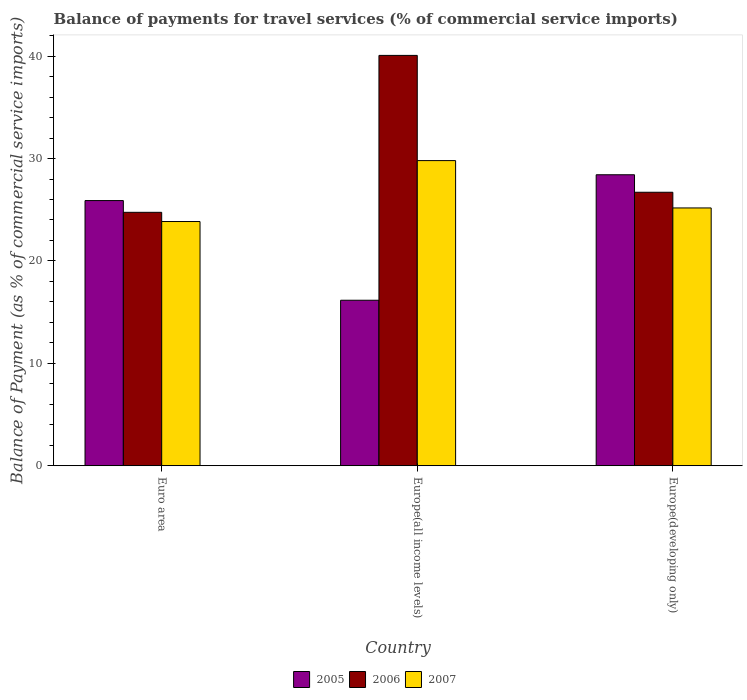How many different coloured bars are there?
Offer a very short reply. 3. Are the number of bars on each tick of the X-axis equal?
Keep it short and to the point. Yes. How many bars are there on the 2nd tick from the left?
Make the answer very short. 3. How many bars are there on the 3rd tick from the right?
Your answer should be compact. 3. What is the label of the 2nd group of bars from the left?
Your answer should be very brief. Europe(all income levels). In how many cases, is the number of bars for a given country not equal to the number of legend labels?
Offer a terse response. 0. What is the balance of payments for travel services in 2007 in Europe(all income levels)?
Offer a very short reply. 29.8. Across all countries, what is the maximum balance of payments for travel services in 2005?
Ensure brevity in your answer.  28.42. Across all countries, what is the minimum balance of payments for travel services in 2007?
Offer a terse response. 23.85. In which country was the balance of payments for travel services in 2006 maximum?
Your answer should be very brief. Europe(all income levels). What is the total balance of payments for travel services in 2007 in the graph?
Your answer should be very brief. 78.82. What is the difference between the balance of payments for travel services in 2007 in Euro area and that in Europe(developing only)?
Make the answer very short. -1.33. What is the difference between the balance of payments for travel services in 2005 in Europe(all income levels) and the balance of payments for travel services in 2007 in Euro area?
Make the answer very short. -7.69. What is the average balance of payments for travel services in 2007 per country?
Make the answer very short. 26.27. What is the difference between the balance of payments for travel services of/in 2007 and balance of payments for travel services of/in 2006 in Europe(all income levels)?
Give a very brief answer. -10.27. What is the ratio of the balance of payments for travel services in 2005 in Euro area to that in Europe(all income levels)?
Provide a succinct answer. 1.6. Is the balance of payments for travel services in 2005 in Euro area less than that in Europe(developing only)?
Your answer should be compact. Yes. What is the difference between the highest and the second highest balance of payments for travel services in 2006?
Your answer should be compact. 15.33. What is the difference between the highest and the lowest balance of payments for travel services in 2005?
Provide a short and direct response. 12.25. In how many countries, is the balance of payments for travel services in 2006 greater than the average balance of payments for travel services in 2006 taken over all countries?
Ensure brevity in your answer.  1. What does the 1st bar from the right in Europe(developing only) represents?
Provide a short and direct response. 2007. Is it the case that in every country, the sum of the balance of payments for travel services in 2005 and balance of payments for travel services in 2007 is greater than the balance of payments for travel services in 2006?
Your answer should be compact. Yes. How many bars are there?
Your answer should be very brief. 9. How many countries are there in the graph?
Give a very brief answer. 3. Does the graph contain any zero values?
Make the answer very short. No. Does the graph contain grids?
Offer a very short reply. No. Where does the legend appear in the graph?
Your answer should be very brief. Bottom center. How many legend labels are there?
Keep it short and to the point. 3. How are the legend labels stacked?
Provide a short and direct response. Horizontal. What is the title of the graph?
Provide a succinct answer. Balance of payments for travel services (% of commercial service imports). Does "1988" appear as one of the legend labels in the graph?
Make the answer very short. No. What is the label or title of the X-axis?
Your answer should be very brief. Country. What is the label or title of the Y-axis?
Offer a very short reply. Balance of Payment (as % of commercial service imports). What is the Balance of Payment (as % of commercial service imports) of 2005 in Euro area?
Keep it short and to the point. 25.89. What is the Balance of Payment (as % of commercial service imports) of 2006 in Euro area?
Your answer should be very brief. 24.75. What is the Balance of Payment (as % of commercial service imports) of 2007 in Euro area?
Your answer should be compact. 23.85. What is the Balance of Payment (as % of commercial service imports) in 2005 in Europe(all income levels)?
Your response must be concise. 16.16. What is the Balance of Payment (as % of commercial service imports) in 2006 in Europe(all income levels)?
Give a very brief answer. 40.07. What is the Balance of Payment (as % of commercial service imports) of 2007 in Europe(all income levels)?
Make the answer very short. 29.8. What is the Balance of Payment (as % of commercial service imports) of 2005 in Europe(developing only)?
Your answer should be compact. 28.42. What is the Balance of Payment (as % of commercial service imports) of 2006 in Europe(developing only)?
Give a very brief answer. 26.71. What is the Balance of Payment (as % of commercial service imports) of 2007 in Europe(developing only)?
Offer a terse response. 25.17. Across all countries, what is the maximum Balance of Payment (as % of commercial service imports) of 2005?
Provide a short and direct response. 28.42. Across all countries, what is the maximum Balance of Payment (as % of commercial service imports) of 2006?
Keep it short and to the point. 40.07. Across all countries, what is the maximum Balance of Payment (as % of commercial service imports) in 2007?
Your answer should be very brief. 29.8. Across all countries, what is the minimum Balance of Payment (as % of commercial service imports) of 2005?
Keep it short and to the point. 16.16. Across all countries, what is the minimum Balance of Payment (as % of commercial service imports) of 2006?
Offer a terse response. 24.75. Across all countries, what is the minimum Balance of Payment (as % of commercial service imports) of 2007?
Offer a terse response. 23.85. What is the total Balance of Payment (as % of commercial service imports) in 2005 in the graph?
Provide a succinct answer. 70.47. What is the total Balance of Payment (as % of commercial service imports) of 2006 in the graph?
Offer a very short reply. 91.52. What is the total Balance of Payment (as % of commercial service imports) in 2007 in the graph?
Keep it short and to the point. 78.82. What is the difference between the Balance of Payment (as % of commercial service imports) in 2005 in Euro area and that in Europe(all income levels)?
Your answer should be very brief. 9.73. What is the difference between the Balance of Payment (as % of commercial service imports) of 2006 in Euro area and that in Europe(all income levels)?
Keep it short and to the point. -15.33. What is the difference between the Balance of Payment (as % of commercial service imports) in 2007 in Euro area and that in Europe(all income levels)?
Your response must be concise. -5.95. What is the difference between the Balance of Payment (as % of commercial service imports) in 2005 in Euro area and that in Europe(developing only)?
Provide a succinct answer. -2.52. What is the difference between the Balance of Payment (as % of commercial service imports) of 2006 in Euro area and that in Europe(developing only)?
Ensure brevity in your answer.  -1.96. What is the difference between the Balance of Payment (as % of commercial service imports) in 2007 in Euro area and that in Europe(developing only)?
Keep it short and to the point. -1.33. What is the difference between the Balance of Payment (as % of commercial service imports) in 2005 in Europe(all income levels) and that in Europe(developing only)?
Make the answer very short. -12.25. What is the difference between the Balance of Payment (as % of commercial service imports) of 2006 in Europe(all income levels) and that in Europe(developing only)?
Your response must be concise. 13.37. What is the difference between the Balance of Payment (as % of commercial service imports) in 2007 in Europe(all income levels) and that in Europe(developing only)?
Your answer should be compact. 4.62. What is the difference between the Balance of Payment (as % of commercial service imports) in 2005 in Euro area and the Balance of Payment (as % of commercial service imports) in 2006 in Europe(all income levels)?
Your answer should be very brief. -14.18. What is the difference between the Balance of Payment (as % of commercial service imports) of 2005 in Euro area and the Balance of Payment (as % of commercial service imports) of 2007 in Europe(all income levels)?
Keep it short and to the point. -3.9. What is the difference between the Balance of Payment (as % of commercial service imports) of 2006 in Euro area and the Balance of Payment (as % of commercial service imports) of 2007 in Europe(all income levels)?
Your answer should be very brief. -5.05. What is the difference between the Balance of Payment (as % of commercial service imports) of 2005 in Euro area and the Balance of Payment (as % of commercial service imports) of 2006 in Europe(developing only)?
Ensure brevity in your answer.  -0.81. What is the difference between the Balance of Payment (as % of commercial service imports) in 2005 in Euro area and the Balance of Payment (as % of commercial service imports) in 2007 in Europe(developing only)?
Your answer should be compact. 0.72. What is the difference between the Balance of Payment (as % of commercial service imports) of 2006 in Euro area and the Balance of Payment (as % of commercial service imports) of 2007 in Europe(developing only)?
Provide a succinct answer. -0.43. What is the difference between the Balance of Payment (as % of commercial service imports) of 2005 in Europe(all income levels) and the Balance of Payment (as % of commercial service imports) of 2006 in Europe(developing only)?
Your answer should be very brief. -10.55. What is the difference between the Balance of Payment (as % of commercial service imports) in 2005 in Europe(all income levels) and the Balance of Payment (as % of commercial service imports) in 2007 in Europe(developing only)?
Your response must be concise. -9.01. What is the difference between the Balance of Payment (as % of commercial service imports) in 2006 in Europe(all income levels) and the Balance of Payment (as % of commercial service imports) in 2007 in Europe(developing only)?
Keep it short and to the point. 14.9. What is the average Balance of Payment (as % of commercial service imports) of 2005 per country?
Provide a short and direct response. 23.49. What is the average Balance of Payment (as % of commercial service imports) of 2006 per country?
Ensure brevity in your answer.  30.51. What is the average Balance of Payment (as % of commercial service imports) of 2007 per country?
Ensure brevity in your answer.  26.27. What is the difference between the Balance of Payment (as % of commercial service imports) in 2005 and Balance of Payment (as % of commercial service imports) in 2006 in Euro area?
Ensure brevity in your answer.  1.15. What is the difference between the Balance of Payment (as % of commercial service imports) in 2005 and Balance of Payment (as % of commercial service imports) in 2007 in Euro area?
Keep it short and to the point. 2.05. What is the difference between the Balance of Payment (as % of commercial service imports) of 2006 and Balance of Payment (as % of commercial service imports) of 2007 in Euro area?
Your response must be concise. 0.9. What is the difference between the Balance of Payment (as % of commercial service imports) in 2005 and Balance of Payment (as % of commercial service imports) in 2006 in Europe(all income levels)?
Ensure brevity in your answer.  -23.91. What is the difference between the Balance of Payment (as % of commercial service imports) in 2005 and Balance of Payment (as % of commercial service imports) in 2007 in Europe(all income levels)?
Make the answer very short. -13.64. What is the difference between the Balance of Payment (as % of commercial service imports) in 2006 and Balance of Payment (as % of commercial service imports) in 2007 in Europe(all income levels)?
Give a very brief answer. 10.27. What is the difference between the Balance of Payment (as % of commercial service imports) of 2005 and Balance of Payment (as % of commercial service imports) of 2006 in Europe(developing only)?
Provide a short and direct response. 1.71. What is the difference between the Balance of Payment (as % of commercial service imports) in 2005 and Balance of Payment (as % of commercial service imports) in 2007 in Europe(developing only)?
Your response must be concise. 3.24. What is the difference between the Balance of Payment (as % of commercial service imports) in 2006 and Balance of Payment (as % of commercial service imports) in 2007 in Europe(developing only)?
Provide a succinct answer. 1.53. What is the ratio of the Balance of Payment (as % of commercial service imports) in 2005 in Euro area to that in Europe(all income levels)?
Your answer should be very brief. 1.6. What is the ratio of the Balance of Payment (as % of commercial service imports) in 2006 in Euro area to that in Europe(all income levels)?
Your answer should be very brief. 0.62. What is the ratio of the Balance of Payment (as % of commercial service imports) of 2007 in Euro area to that in Europe(all income levels)?
Your response must be concise. 0.8. What is the ratio of the Balance of Payment (as % of commercial service imports) of 2005 in Euro area to that in Europe(developing only)?
Offer a terse response. 0.91. What is the ratio of the Balance of Payment (as % of commercial service imports) of 2006 in Euro area to that in Europe(developing only)?
Keep it short and to the point. 0.93. What is the ratio of the Balance of Payment (as % of commercial service imports) of 2007 in Euro area to that in Europe(developing only)?
Keep it short and to the point. 0.95. What is the ratio of the Balance of Payment (as % of commercial service imports) of 2005 in Europe(all income levels) to that in Europe(developing only)?
Your response must be concise. 0.57. What is the ratio of the Balance of Payment (as % of commercial service imports) in 2006 in Europe(all income levels) to that in Europe(developing only)?
Keep it short and to the point. 1.5. What is the ratio of the Balance of Payment (as % of commercial service imports) of 2007 in Europe(all income levels) to that in Europe(developing only)?
Your answer should be very brief. 1.18. What is the difference between the highest and the second highest Balance of Payment (as % of commercial service imports) in 2005?
Keep it short and to the point. 2.52. What is the difference between the highest and the second highest Balance of Payment (as % of commercial service imports) in 2006?
Provide a succinct answer. 13.37. What is the difference between the highest and the second highest Balance of Payment (as % of commercial service imports) of 2007?
Ensure brevity in your answer.  4.62. What is the difference between the highest and the lowest Balance of Payment (as % of commercial service imports) of 2005?
Your answer should be very brief. 12.25. What is the difference between the highest and the lowest Balance of Payment (as % of commercial service imports) in 2006?
Offer a terse response. 15.33. What is the difference between the highest and the lowest Balance of Payment (as % of commercial service imports) of 2007?
Offer a terse response. 5.95. 